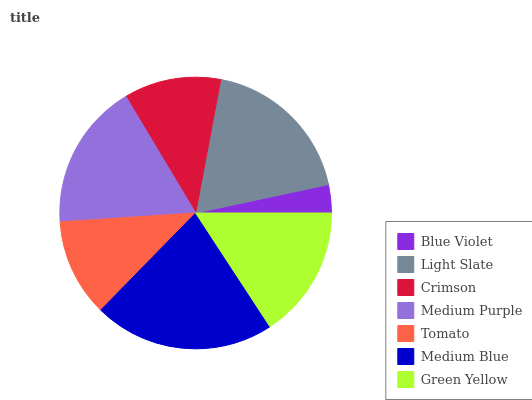Is Blue Violet the minimum?
Answer yes or no. Yes. Is Medium Blue the maximum?
Answer yes or no. Yes. Is Light Slate the minimum?
Answer yes or no. No. Is Light Slate the maximum?
Answer yes or no. No. Is Light Slate greater than Blue Violet?
Answer yes or no. Yes. Is Blue Violet less than Light Slate?
Answer yes or no. Yes. Is Blue Violet greater than Light Slate?
Answer yes or no. No. Is Light Slate less than Blue Violet?
Answer yes or no. No. Is Green Yellow the high median?
Answer yes or no. Yes. Is Green Yellow the low median?
Answer yes or no. Yes. Is Light Slate the high median?
Answer yes or no. No. Is Light Slate the low median?
Answer yes or no. No. 